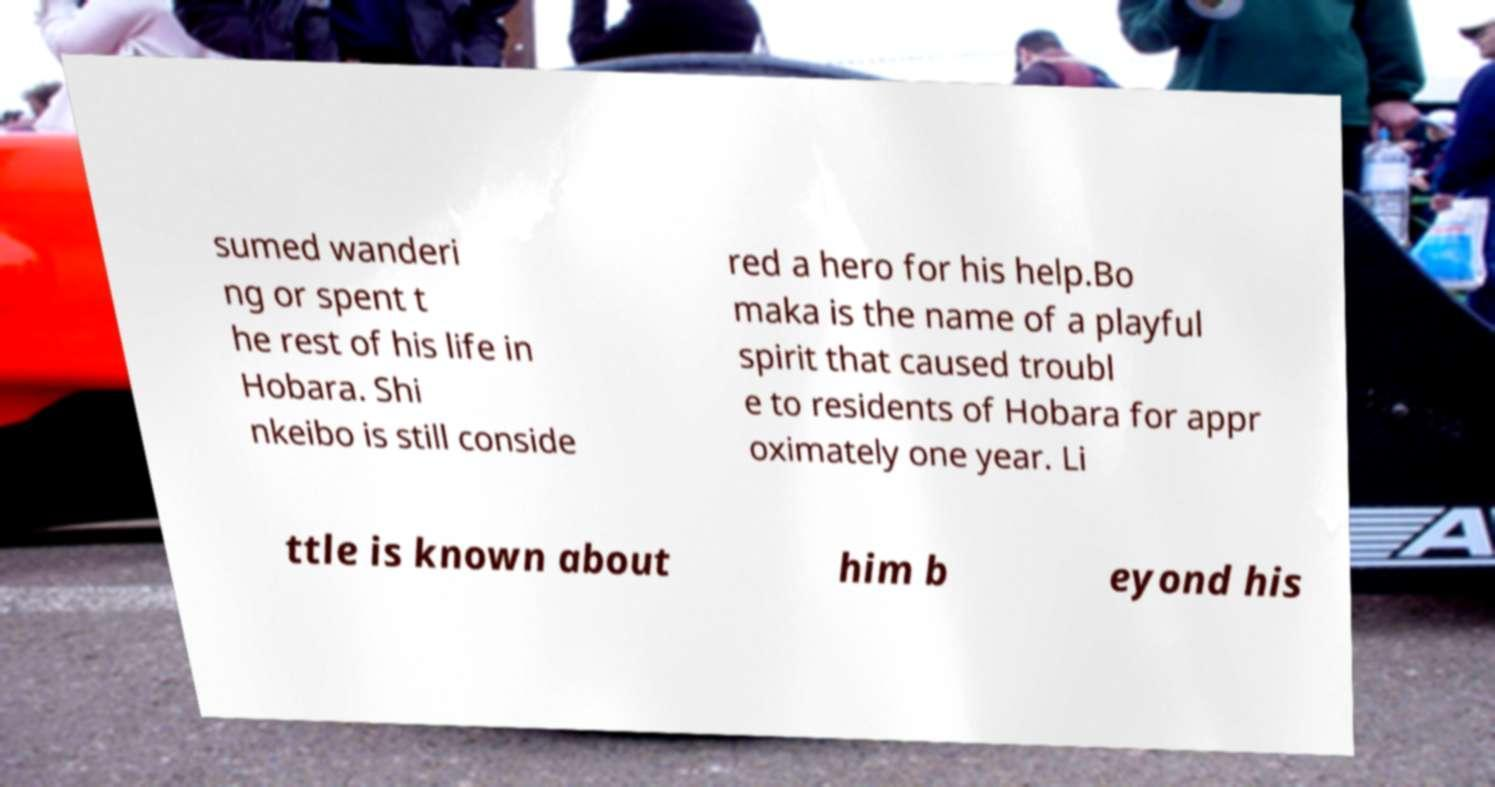Could you extract and type out the text from this image? sumed wanderi ng or spent t he rest of his life in Hobara. Shi nkeibo is still conside red a hero for his help.Bo maka is the name of a playful spirit that caused troubl e to residents of Hobara for appr oximately one year. Li ttle is known about him b eyond his 